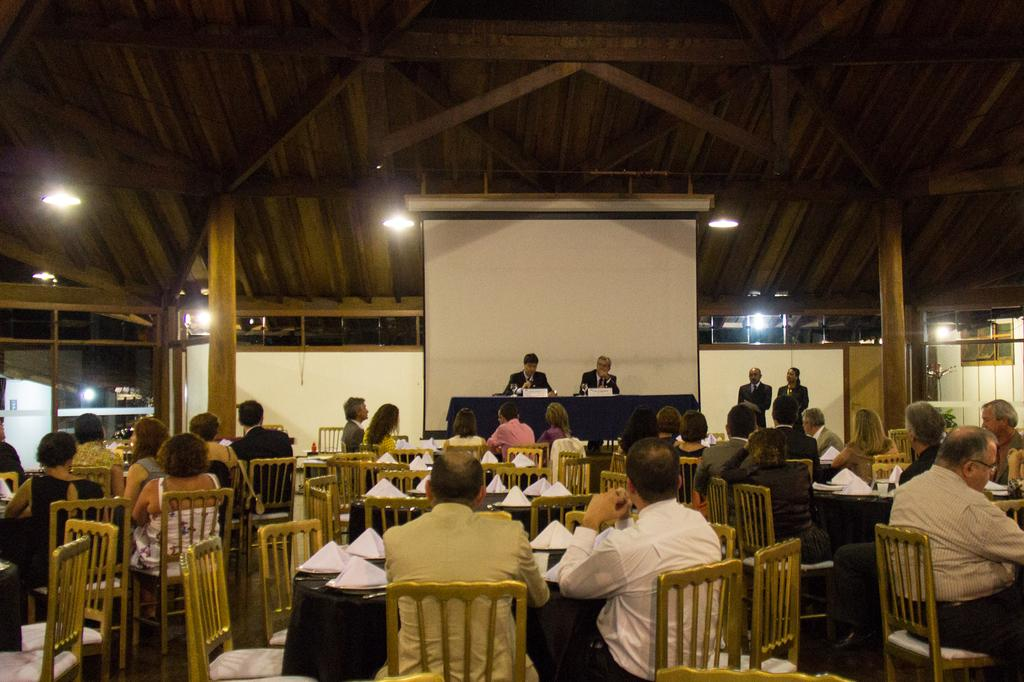What is the main object in the image? There is a white color screen in the image. What are the people in the image doing? The people in the image are sitting on chairs. What type of sticks can be seen being used by the people in the image? There are no sticks visible in the image; the people are sitting on chairs. What type of party is being held in the image? There is no indication of a party in the image; it only shows a white color screen and people sitting on chairs. 